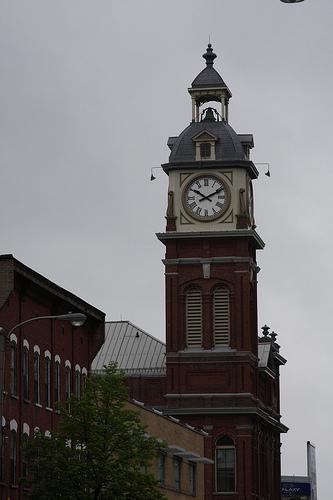How many roman numerals are on the clock?
Give a very brief answer. 12. How many hands does the clock have?
Give a very brief answer. 2. How many street lights are visible?
Give a very brief answer. 1. 